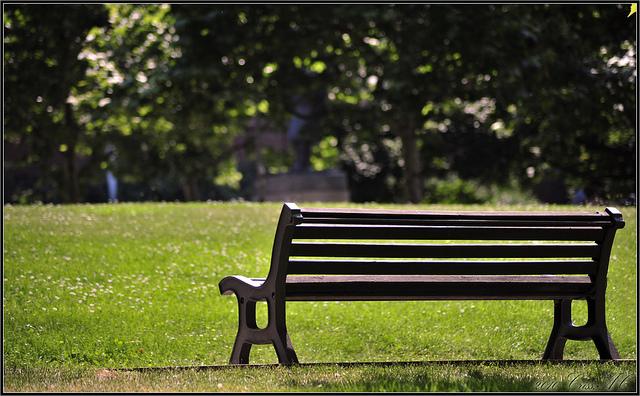Does this location appear to be in a drought?
Give a very brief answer. No. How many park benches do you see?
Quick response, please. 1. Where do you think this is located?
Write a very short answer. Park. 